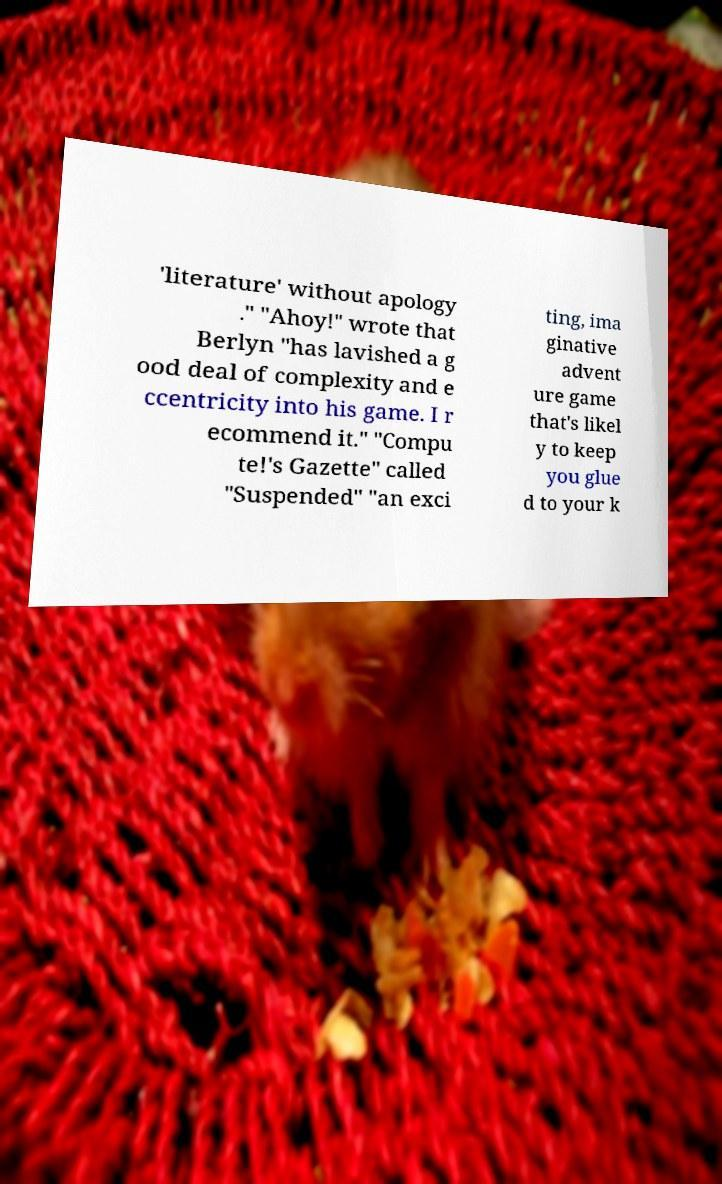Please read and relay the text visible in this image. What does it say? 'literature' without apology ." "Ahoy!" wrote that Berlyn "has lavished a g ood deal of complexity and e ccentricity into his game. I r ecommend it." "Compu te!'s Gazette" called "Suspended" "an exci ting, ima ginative advent ure game that's likel y to keep you glue d to your k 